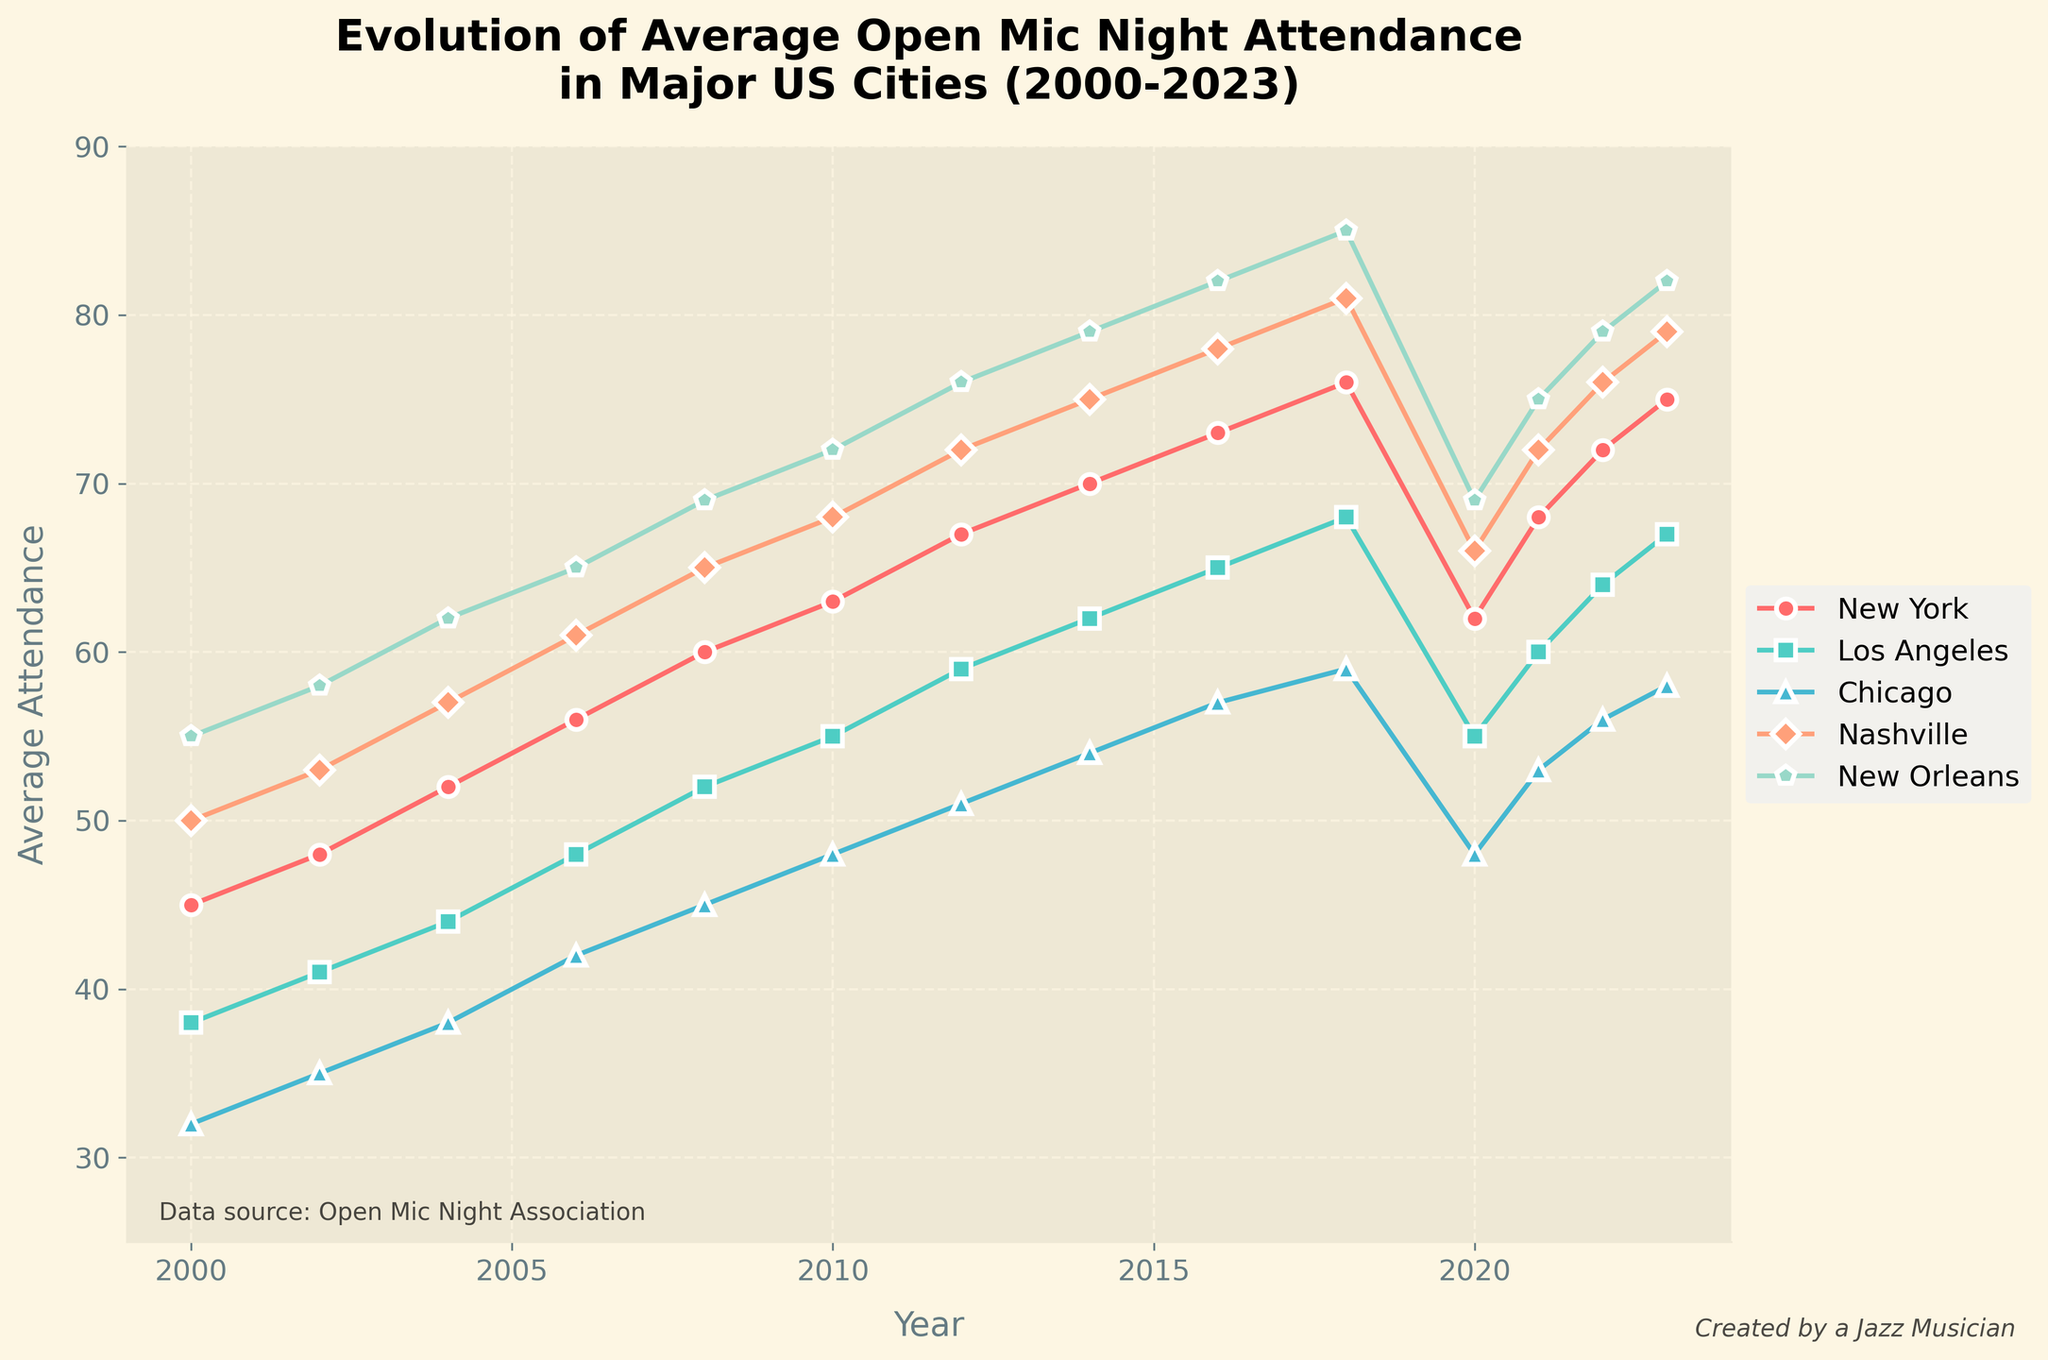What's the general trend of average open mic night attendance in New Orleans from 2000 to 2023? New Orleans shows a general increasing trend from 2000 to 2018, peaks in 2018, dips in 2020, and then rises again from 2021 to 2023.
Answer: Increasing overall trend with slight fluctuations Which city had the highest average attendance in 2023? According to the chart, New Orleans had the highest average attendance in 2023.
Answer: New Orleans During which years did New York's attendance increase by 5 or more between two consecutive data points? New York's attendance increased by 5 or more between 2010-2012 (63 to 67) and 2021-2022 (68 to 72).
Answer: 2010-2012, 2021-2022 Did any city have a decline in average attendance between 2018 and 2020? Yes, all cities show a decline in attendance between 2018 and 2020.
Answer: Yes How did the attendance in Nashville change from 2020 to 2023? Nashville's attendance increased from 66 in 2020 to 79 in 2023. Specifically, it was 66 in 2020, 72 in 2021, 76 in 2022, and 79 in 2023.
Answer: Increased Compare the growth in attendance between Los Angeles and Chicago from 2000 to 2023. From 2000 to 2023, Los Angeles' attendance grew from 38 to 67 (an increase of 29), while Chicago's attendance grew from 32 to 58 (an increase of 26).
Answer: Los Angeles had a slightly higher growth Which city had the most stable attendance trend without major fluctuations? Chicago’s attendance shows the most stable trend without major fluctuations, showing gradual and steady increases over the years.
Answer: Chicago What was the average attendance for Nashville in the years 2000, 2010, and 2020? The average attendance for Nashville in 2000, 2010, and 2020 can be calculated by adding these values (50 + 68 + 66) and dividing by 3: (50 + 68 + 66) / 3 = 61.33.
Answer: 61.33 In which year did New York and Los Angeles have equal or nearly equal attendance? New York and Los Angeles had nearly equal attendance in 2020, with New York at 62 and Los Angeles at 55, the smallest gap in the chart.
Answer: 2020 